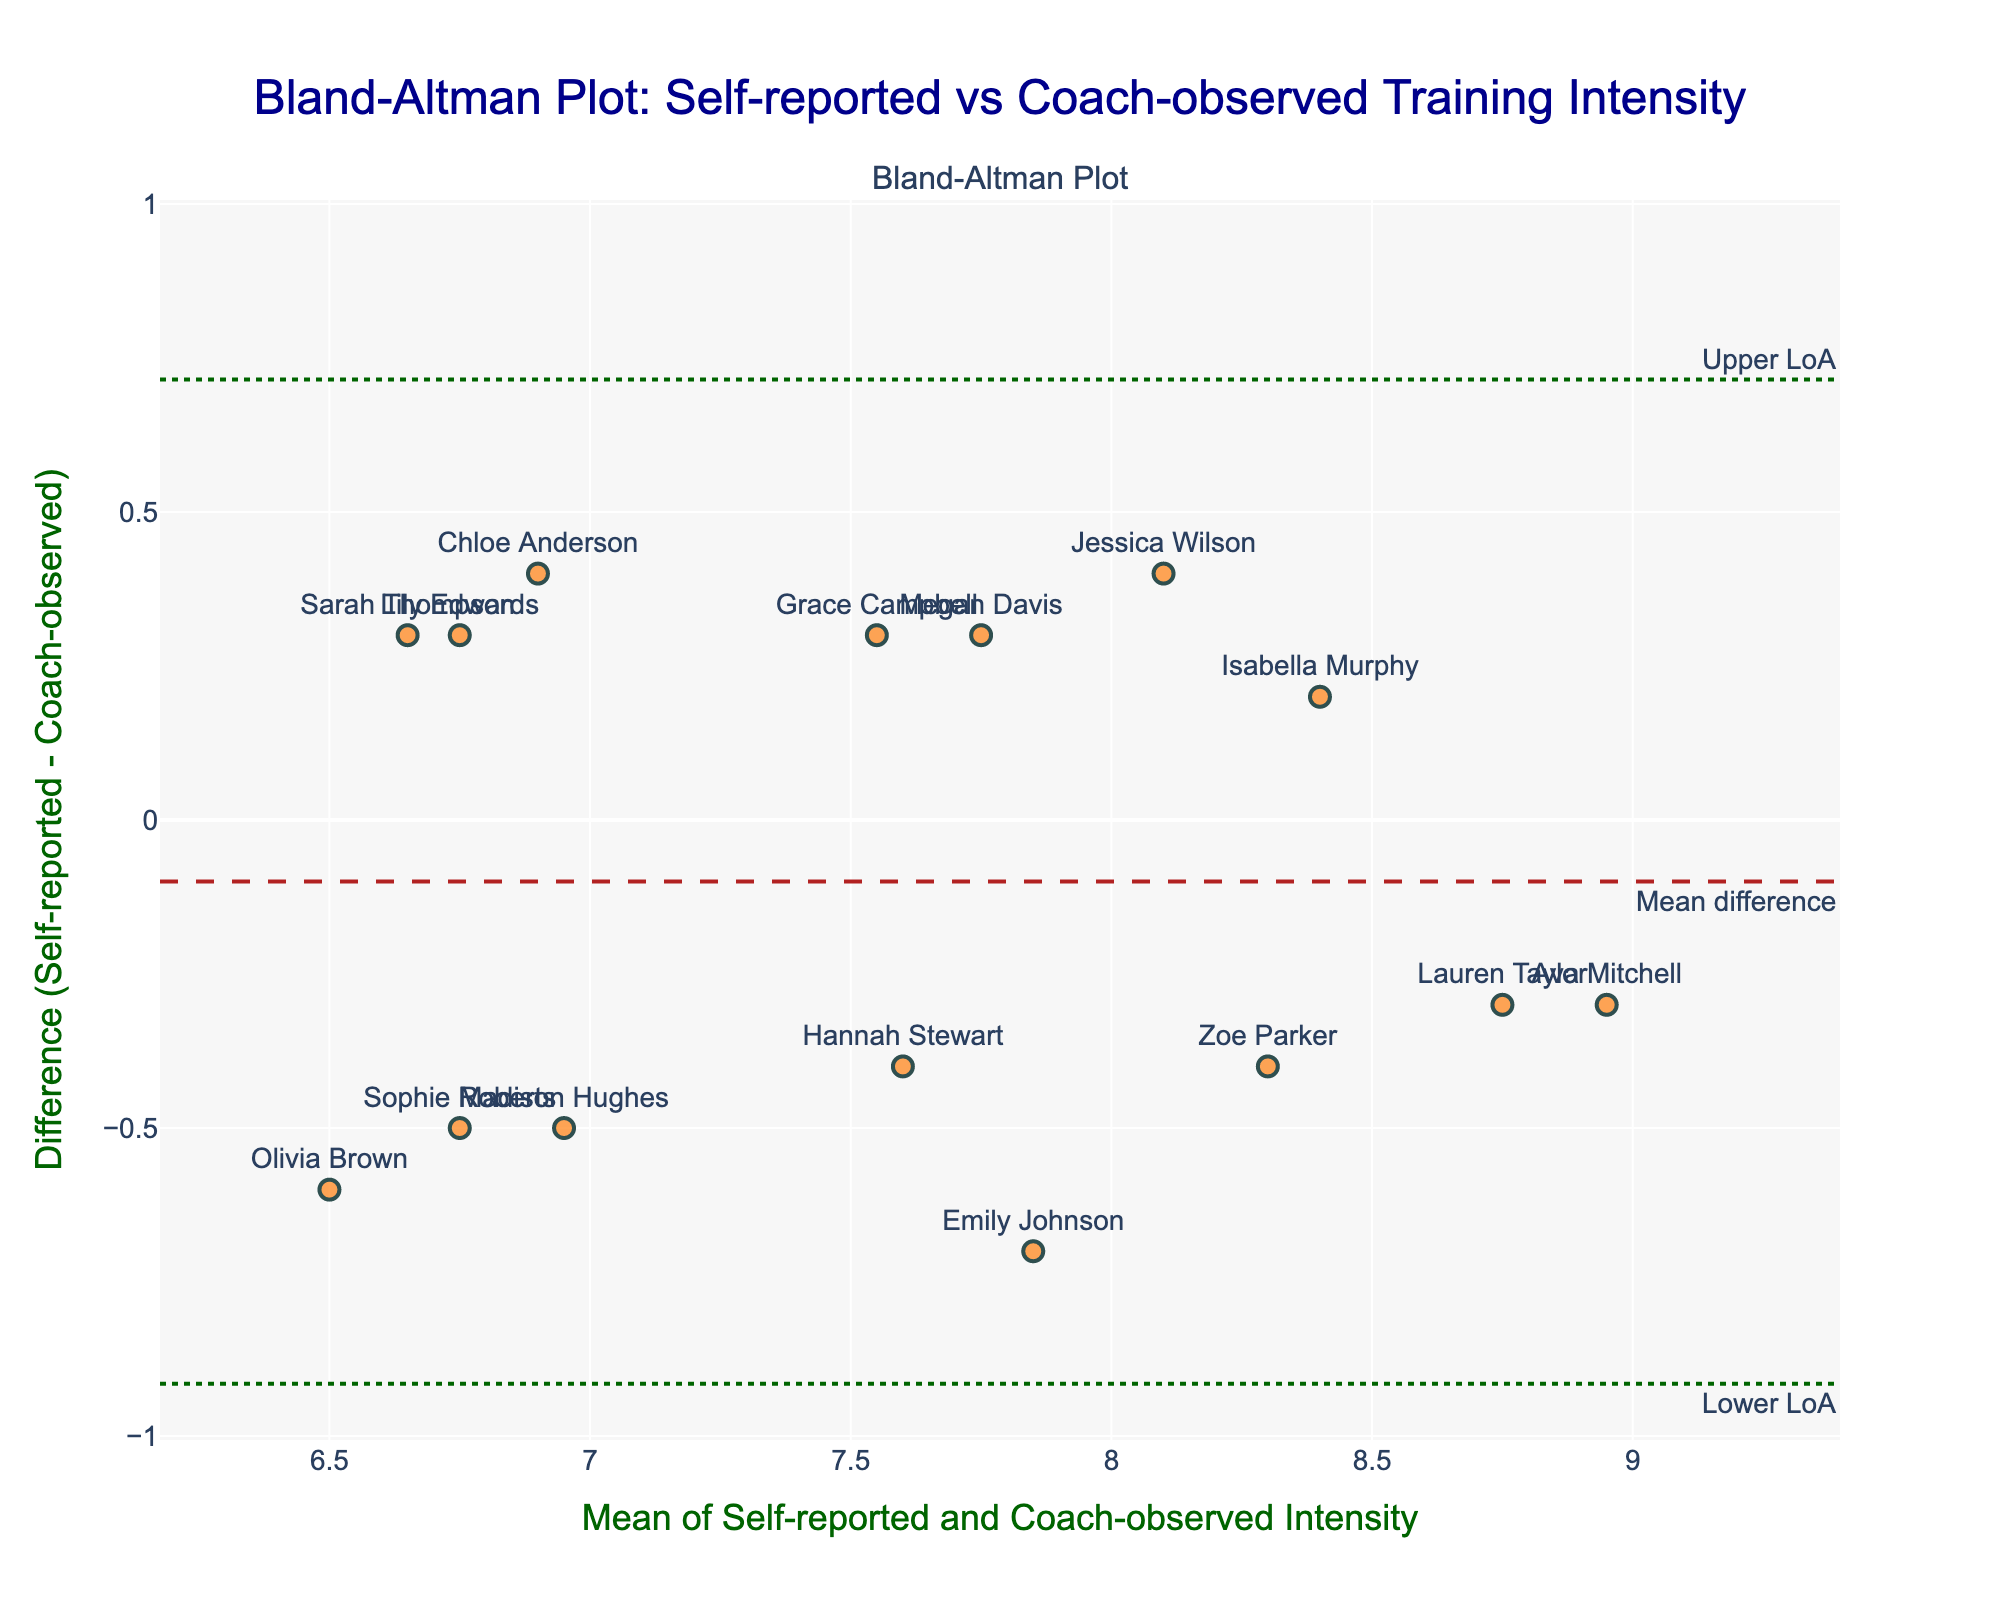How many players are displayed on the plot? Count the number of data points or players' names shown on the plot. This can be obtained directly from the number of markers and associated player labels.
Answer: 15 What is the title of the figure? The title is typically displayed at the top of the plot.
Answer: Bland-Altman Plot: Self-reported vs Coach-observed Training Intensity What is the difference between the self-reported and coach-observed intensity for Emily Johnson? Find the data point labeled with Emily Johnson and note the y-value of that point since the y-axis denotes the difference (Self-reported - Coach-observed).
Answer: -0.7 What is the average self-reported intensity for the players? Sum all self-reported intensities and divide by the number of players. (7.5 + 6.8 + 8.3 + 6.2 + 7.9 + 8.6 + 7.1 + 8.8 + 6.5 + 7.7 + 8.1 + 6.9 + 7.4 + 8.5 + 6.7) / 15 = 7.47
Answer: 7.47 Which player shows the largest positive difference between self-reported and coach-observed intensity? Look for the highest point on the y-axis (indicating the greatest positive difference), and check which player is labeled at that point.
Answer: Olivia Brown Are there more points above or below the mean difference line? Visually count the number of points above and below the dashed red line indicating the mean difference.
Answer: Below What is the mean of the difference between self-reported and coach-observed intensity levels? Look for the value of the dashed red line, which represents the mean difference.
Answer: -0.1 Which player has a mean intensity closest to 7.8? Find the data point closest to 7.8 on the x-axis, which shows the mean of self-reported and coach-observed intensities, and check the player's label.
Answer: Jessica Wilson What are the upper and lower limits of agreement? Look for the values where the dashed green lines are located, labeled as "Upper LoA" and "Lower LoA".
Answer: 1.35, -1.55 What is the range of the y-axis values for difference in intensities? Check the y-axis labels and recount based on the data range from the figure, which is set to accommodate the upper and lower limits of agreement.
Answer: -1.55 to 1.55 